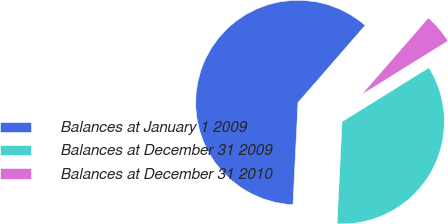Convert chart. <chart><loc_0><loc_0><loc_500><loc_500><pie_chart><fcel>Balances at January 1 2009<fcel>Balances at December 31 2009<fcel>Balances at December 31 2010<nl><fcel>60.62%<fcel>34.63%<fcel>4.75%<nl></chart> 